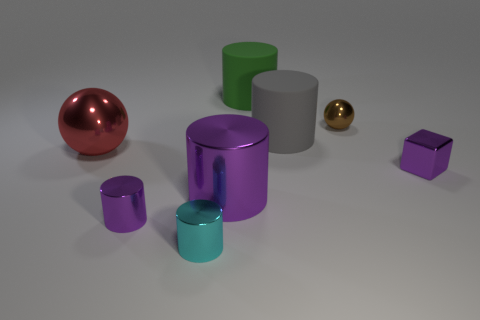Subtract 2 cylinders. How many cylinders are left? 3 Subtract all small cyan cylinders. How many cylinders are left? 4 Subtract all green cylinders. How many cylinders are left? 4 Subtract all gray cylinders. Subtract all gray spheres. How many cylinders are left? 4 Add 1 blocks. How many objects exist? 9 Subtract all cubes. How many objects are left? 7 Add 6 tiny spheres. How many tiny spheres are left? 7 Add 2 red rubber balls. How many red rubber balls exist? 2 Subtract 0 yellow balls. How many objects are left? 8 Subtract all small yellow metal cylinders. Subtract all tiny metallic cubes. How many objects are left? 7 